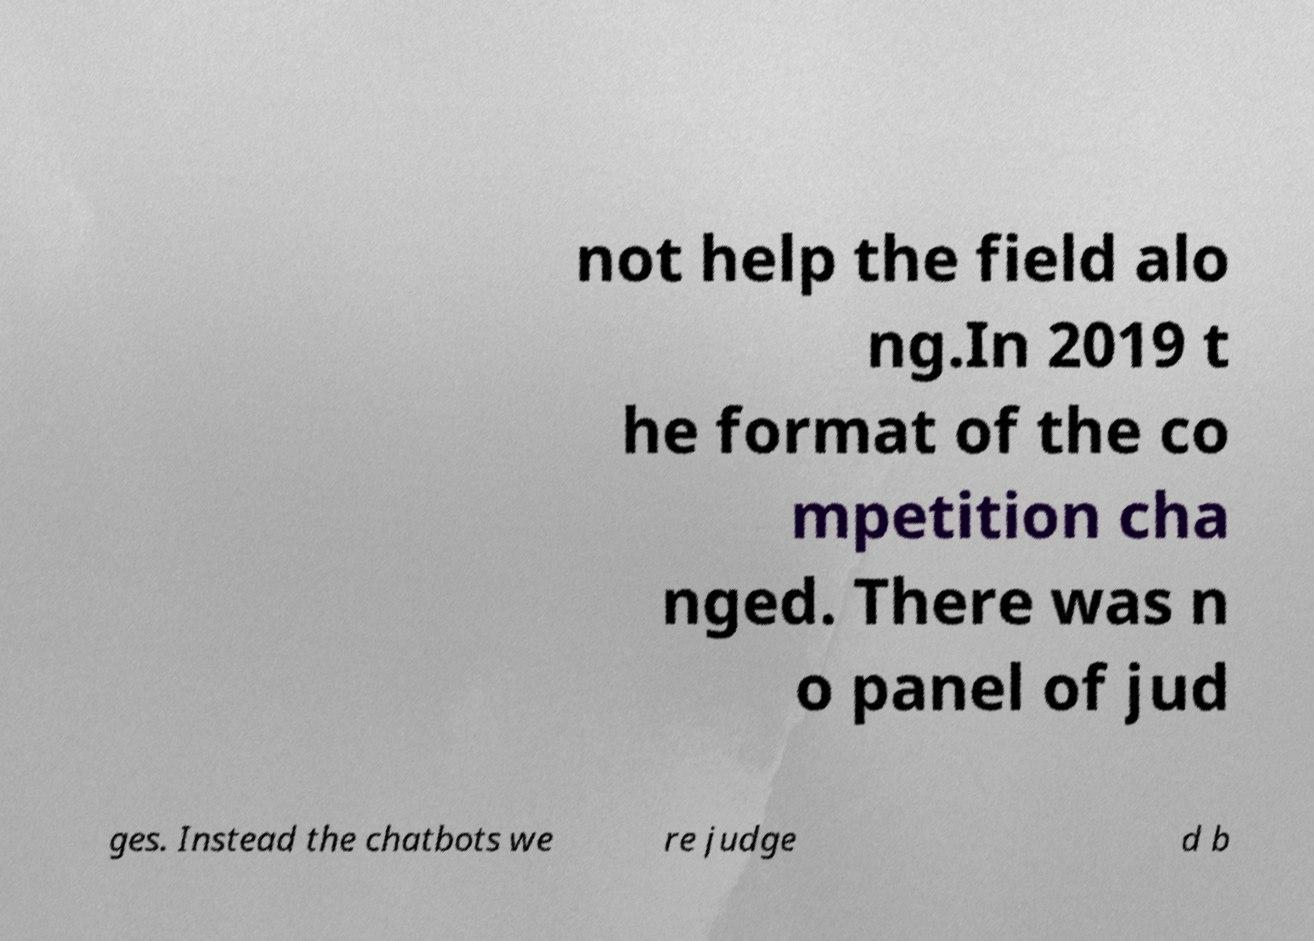There's text embedded in this image that I need extracted. Can you transcribe it verbatim? not help the field alo ng.In 2019 t he format of the co mpetition cha nged. There was n o panel of jud ges. Instead the chatbots we re judge d b 